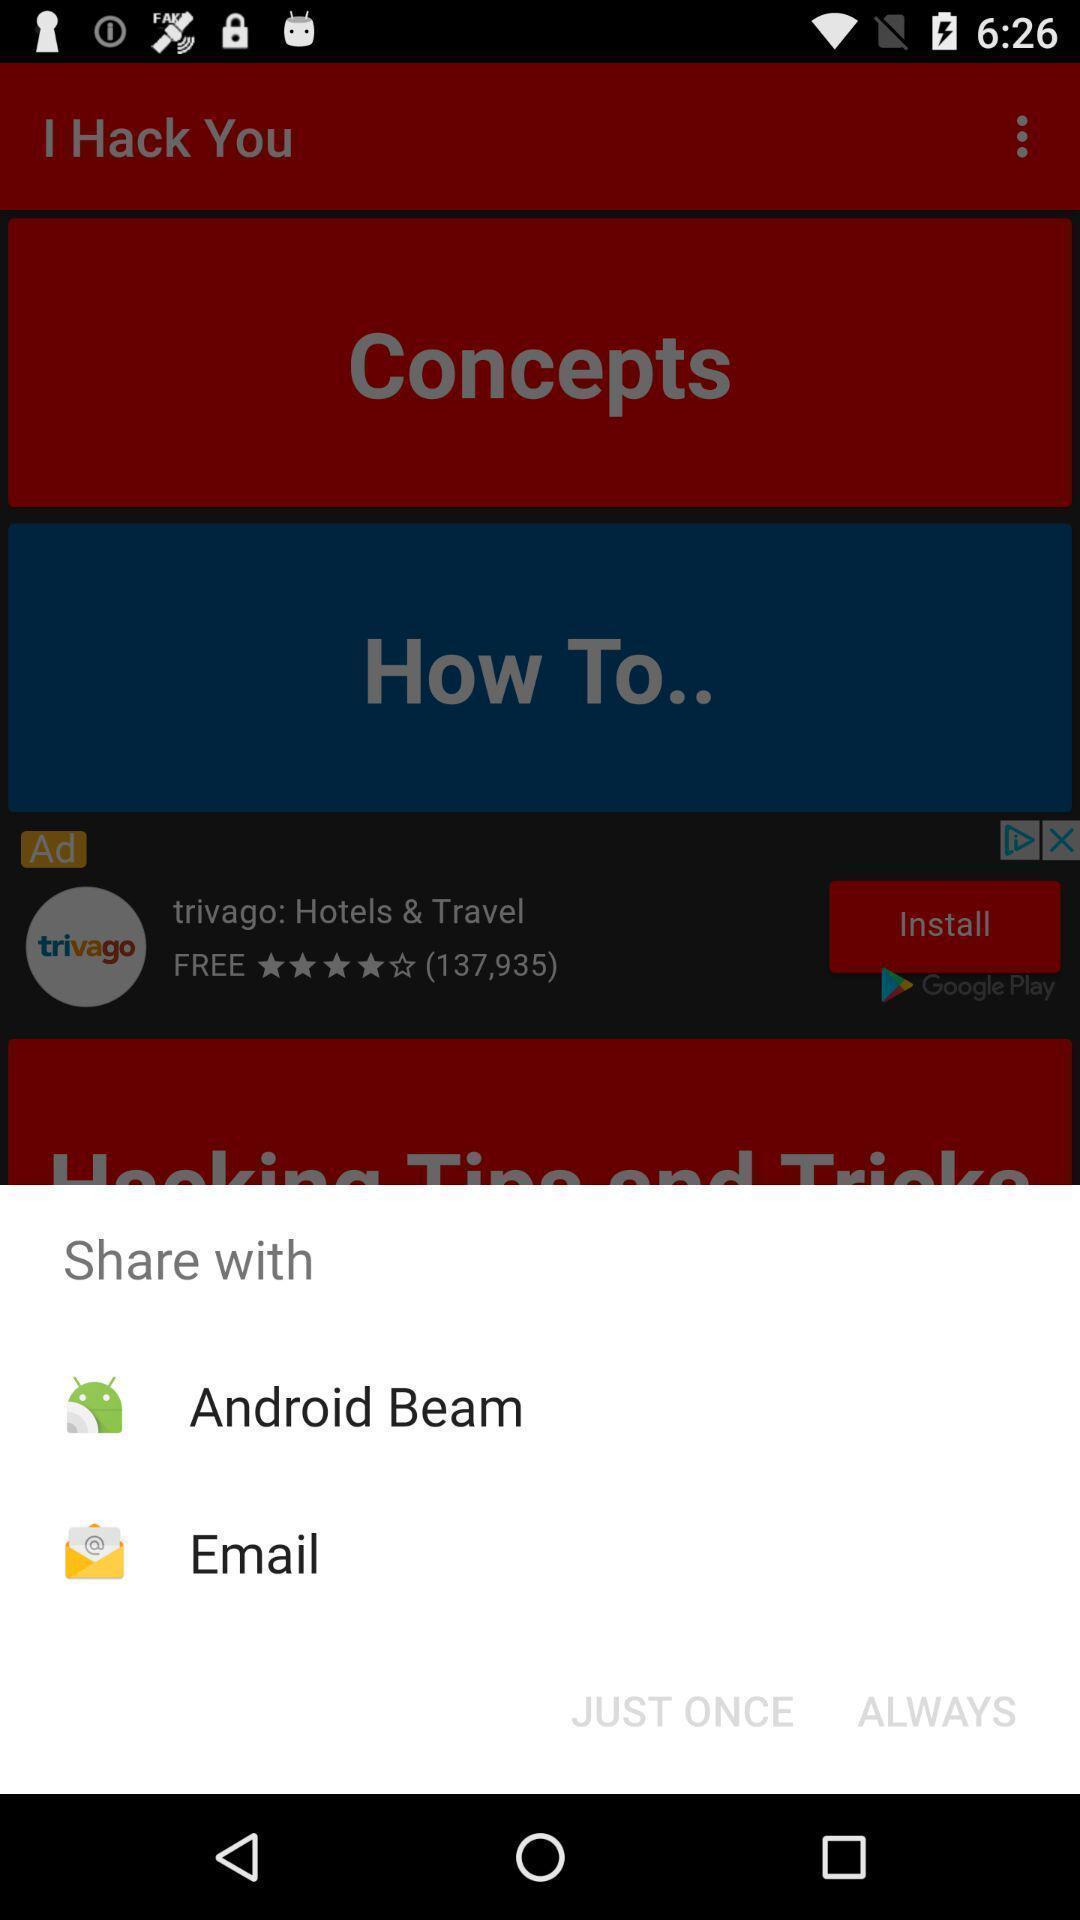Provide a detailed account of this screenshot. Push up message for sharing data via social network. 